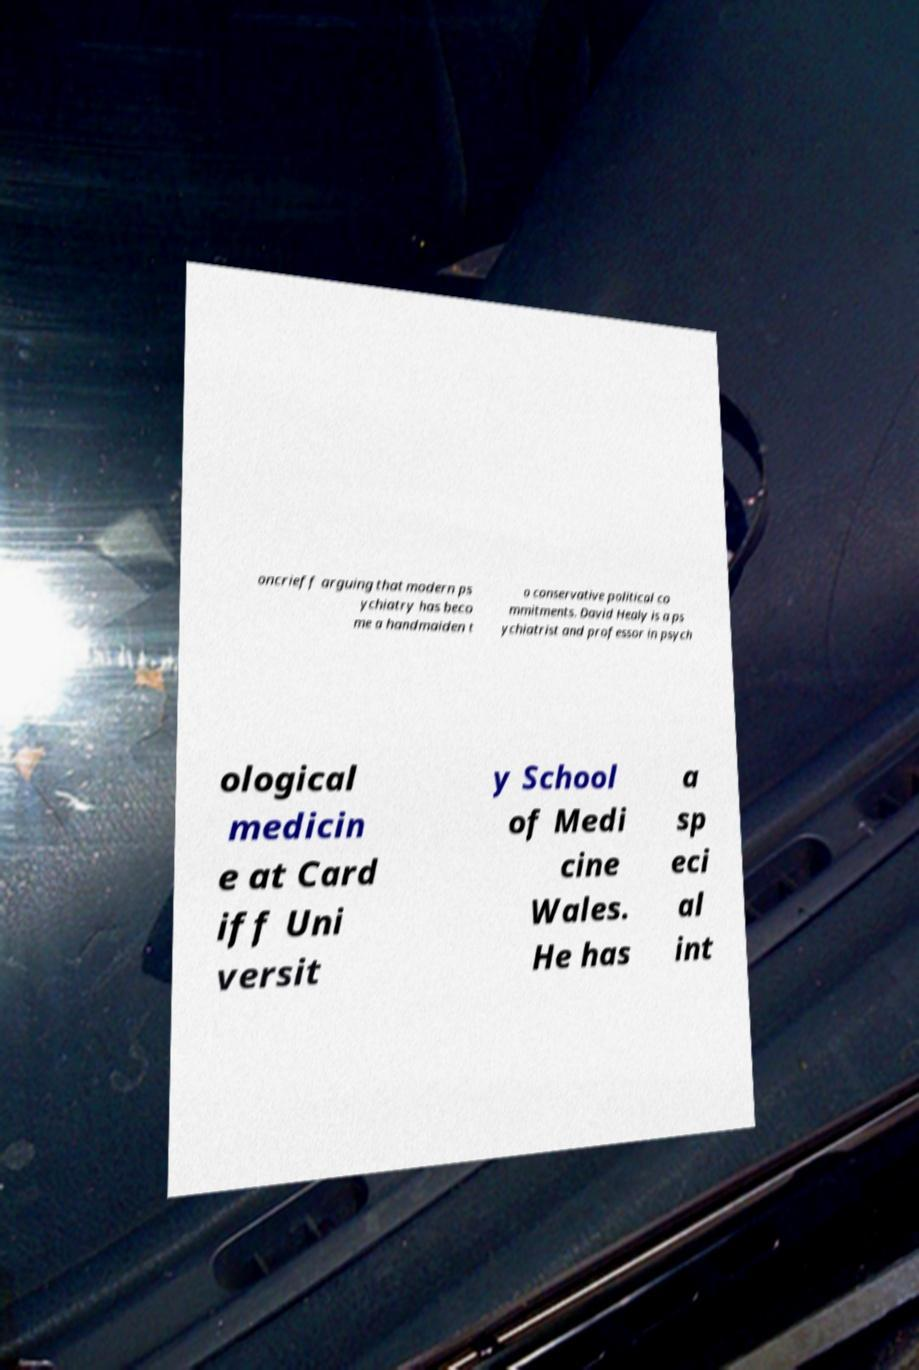Could you extract and type out the text from this image? oncrieff arguing that modern ps ychiatry has beco me a handmaiden t o conservative political co mmitments. David Healy is a ps ychiatrist and professor in psych ological medicin e at Card iff Uni versit y School of Medi cine Wales. He has a sp eci al int 